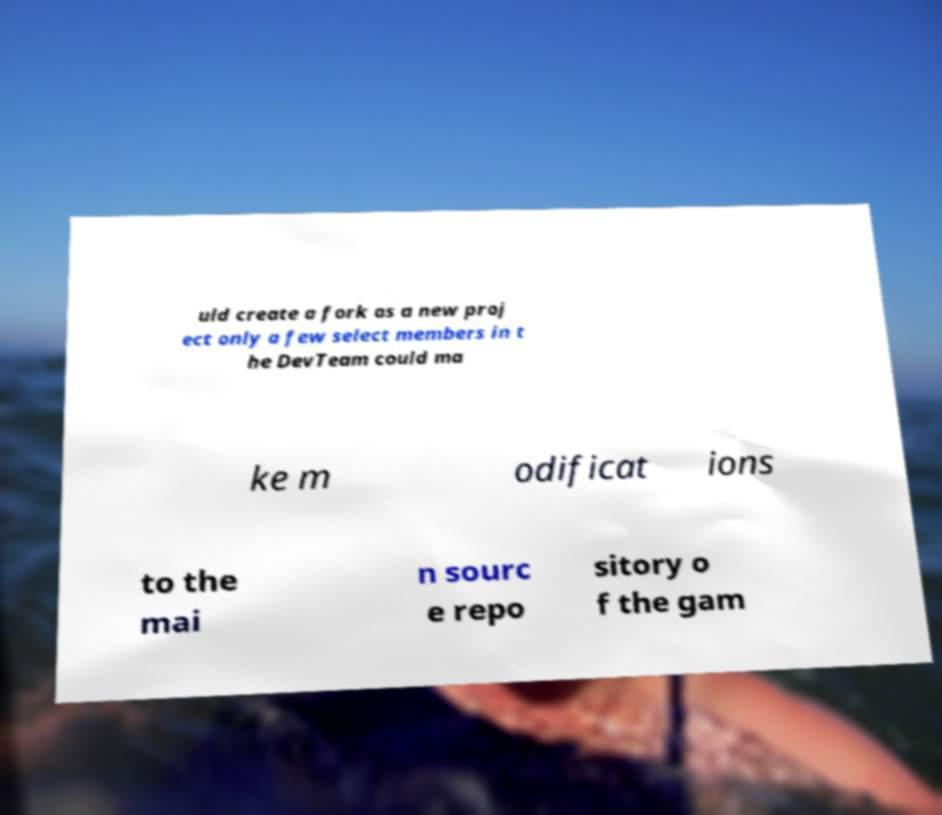There's text embedded in this image that I need extracted. Can you transcribe it verbatim? uld create a fork as a new proj ect only a few select members in t he DevTeam could ma ke m odificat ions to the mai n sourc e repo sitory o f the gam 